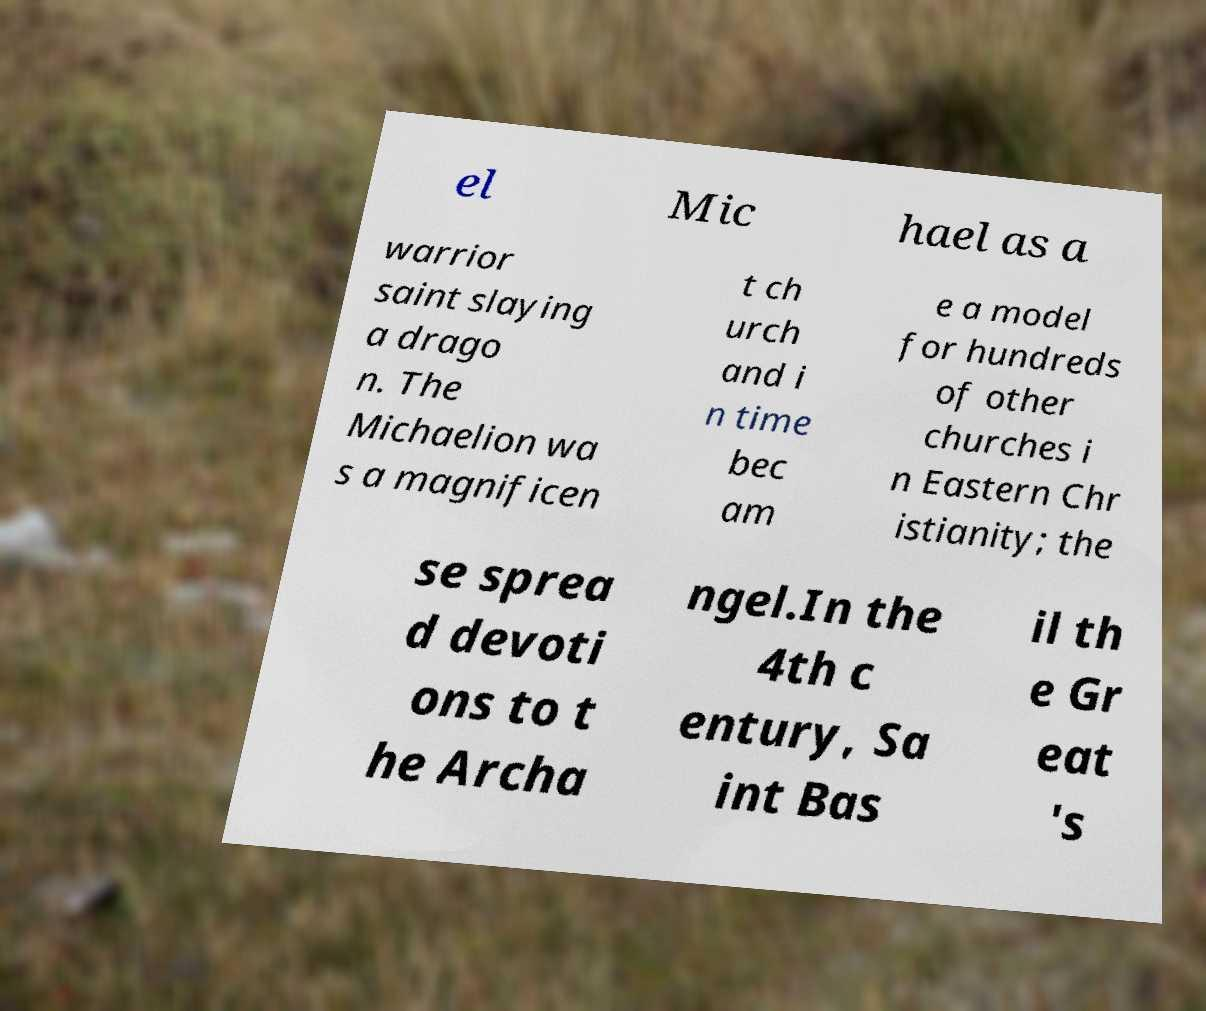I need the written content from this picture converted into text. Can you do that? el Mic hael as a warrior saint slaying a drago n. The Michaelion wa s a magnificen t ch urch and i n time bec am e a model for hundreds of other churches i n Eastern Chr istianity; the se sprea d devoti ons to t he Archa ngel.In the 4th c entury, Sa int Bas il th e Gr eat 's 